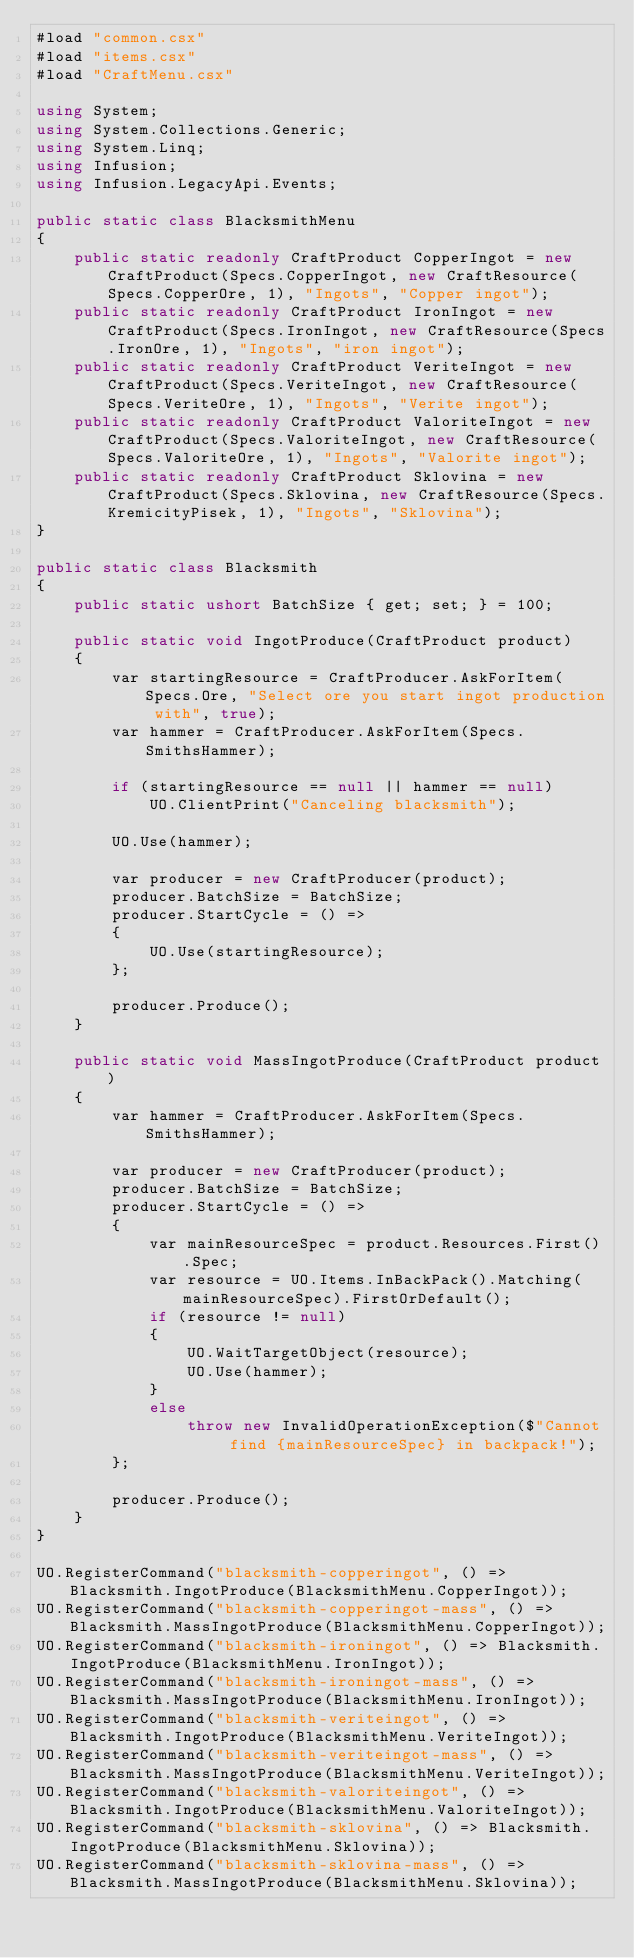<code> <loc_0><loc_0><loc_500><loc_500><_C#_>#load "common.csx"
#load "items.csx"
#load "CraftMenu.csx"

using System;
using System.Collections.Generic;
using System.Linq;
using Infusion;
using Infusion.LegacyApi.Events;

public static class BlacksmithMenu
{    
    public static readonly CraftProduct CopperIngot = new CraftProduct(Specs.CopperIngot, new CraftResource(Specs.CopperOre, 1), "Ingots", "Copper ingot");
    public static readonly CraftProduct IronIngot = new CraftProduct(Specs.IronIngot, new CraftResource(Specs.IronOre, 1), "Ingots", "iron ingot");       
    public static readonly CraftProduct VeriteIngot = new CraftProduct(Specs.VeriteIngot, new CraftResource(Specs.VeriteOre, 1), "Ingots", "Verite ingot");       
    public static readonly CraftProduct ValoriteIngot = new CraftProduct(Specs.ValoriteIngot, new CraftResource(Specs.ValoriteOre, 1), "Ingots", "Valorite ingot");
    public static readonly CraftProduct Sklovina = new CraftProduct(Specs.Sklovina, new CraftResource(Specs.KremicityPisek, 1), "Ingots", "Sklovina");
}

public static class Blacksmith
{
    public static ushort BatchSize { get; set; } = 100;

    public static void IngotProduce(CraftProduct product)
    {
        var startingResource = CraftProducer.AskForItem(Specs.Ore, "Select ore you start ingot production with", true);
        var hammer = CraftProducer.AskForItem(Specs.SmithsHammer);
        
        if (startingResource == null || hammer == null)
            UO.ClientPrint("Canceling blacksmith");
            
        UO.Use(hammer);

        var producer = new CraftProducer(product);
        producer.BatchSize = BatchSize;
        producer.StartCycle = () =>
        {
            UO.Use(startingResource);
        };
        
        producer.Produce();
    }

    public static void MassIngotProduce(CraftProduct product)
    {
        var hammer = CraftProducer.AskForItem(Specs.SmithsHammer);
        
        var producer = new CraftProducer(product);
        producer.BatchSize = BatchSize;
        producer.StartCycle = () =>
        {
            var mainResourceSpec = product.Resources.First().Spec;
            var resource = UO.Items.InBackPack().Matching(mainResourceSpec).FirstOrDefault();
            if (resource != null)
            {
                UO.WaitTargetObject(resource);
                UO.Use(hammer);
            }
            else
                throw new InvalidOperationException($"Cannot find {mainResourceSpec} in backpack!");
        };
        
        producer.Produce();
    }  
}

UO.RegisterCommand("blacksmith-copperingot", () => Blacksmith.IngotProduce(BlacksmithMenu.CopperIngot));
UO.RegisterCommand("blacksmith-copperingot-mass", () => Blacksmith.MassIngotProduce(BlacksmithMenu.CopperIngot));
UO.RegisterCommand("blacksmith-ironingot", () => Blacksmith.IngotProduce(BlacksmithMenu.IronIngot));
UO.RegisterCommand("blacksmith-ironingot-mass", () => Blacksmith.MassIngotProduce(BlacksmithMenu.IronIngot));
UO.RegisterCommand("blacksmith-veriteingot", () => Blacksmith.IngotProduce(BlacksmithMenu.VeriteIngot));
UO.RegisterCommand("blacksmith-veriteingot-mass", () => Blacksmith.MassIngotProduce(BlacksmithMenu.VeriteIngot));
UO.RegisterCommand("blacksmith-valoriteingot", () => Blacksmith.IngotProduce(BlacksmithMenu.ValoriteIngot));
UO.RegisterCommand("blacksmith-sklovina", () => Blacksmith.IngotProduce(BlacksmithMenu.Sklovina));
UO.RegisterCommand("blacksmith-sklovina-mass", () => Blacksmith.MassIngotProduce(BlacksmithMenu.Sklovina));
</code> 